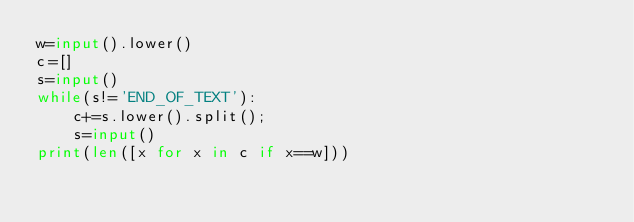<code> <loc_0><loc_0><loc_500><loc_500><_Python_>w=input().lower()
c=[]
s=input()
while(s!='END_OF_TEXT'):
    c+=s.lower().split();
    s=input()
print(len([x for x in c if x==w]))

</code> 